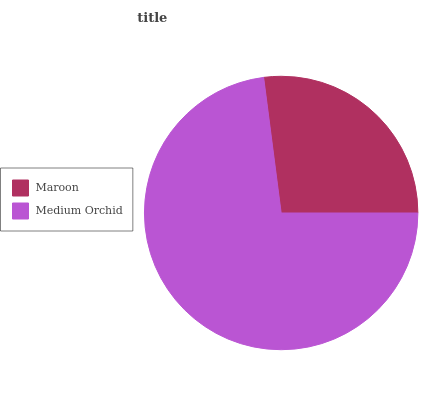Is Maroon the minimum?
Answer yes or no. Yes. Is Medium Orchid the maximum?
Answer yes or no. Yes. Is Medium Orchid the minimum?
Answer yes or no. No. Is Medium Orchid greater than Maroon?
Answer yes or no. Yes. Is Maroon less than Medium Orchid?
Answer yes or no. Yes. Is Maroon greater than Medium Orchid?
Answer yes or no. No. Is Medium Orchid less than Maroon?
Answer yes or no. No. Is Medium Orchid the high median?
Answer yes or no. Yes. Is Maroon the low median?
Answer yes or no. Yes. Is Maroon the high median?
Answer yes or no. No. Is Medium Orchid the low median?
Answer yes or no. No. 